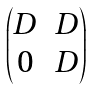Convert formula to latex. <formula><loc_0><loc_0><loc_500><loc_500>\begin{pmatrix} D & D \\ 0 & D \end{pmatrix}</formula> 